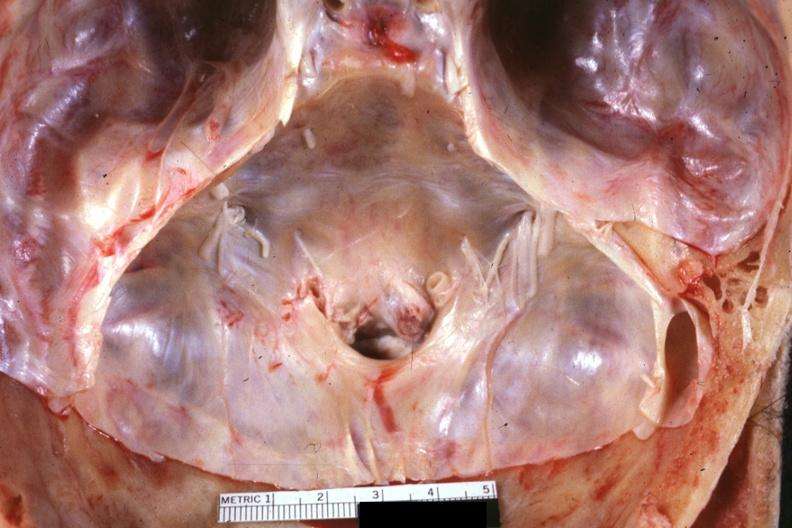what is present?
Answer the question using a single word or phrase. Bone, calvarium 